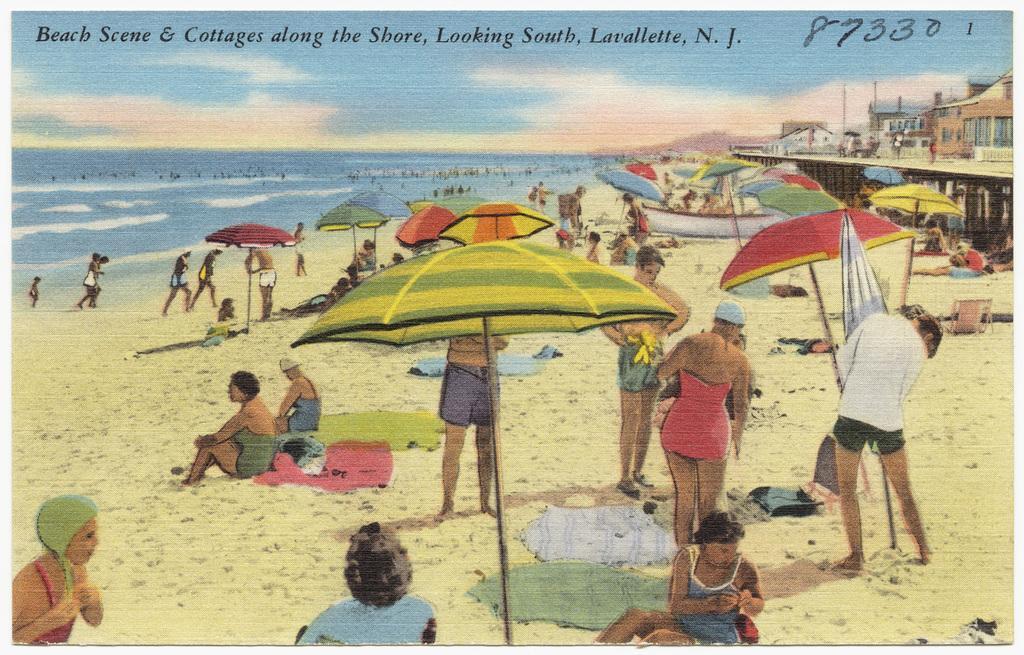Describe this image in one or two sentences. It is an animated image there is a beach and there are many people in front of the beach, they are doing different activities and behind them there are few cottages. 